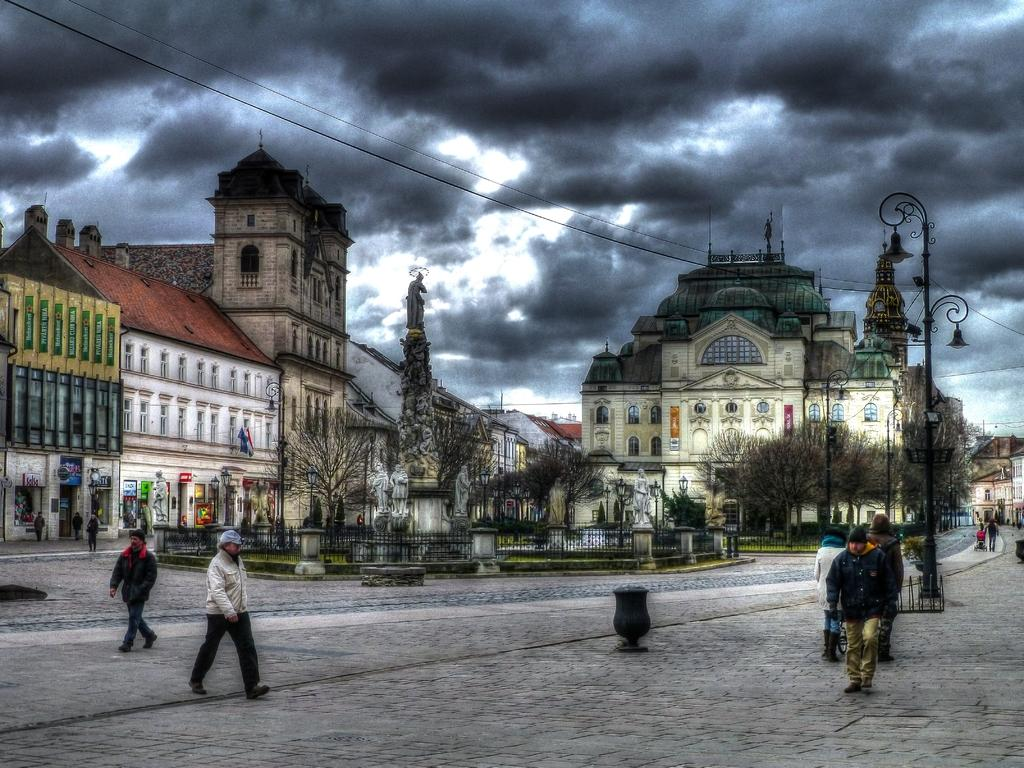What type of surface can be seen in the image? There is ground visible in the image. What are the persons in the image doing? The persons are standing on the ground. What structures can be seen in the image? There are poles, wires, trees, railing, and buildings in the image. What is visible in the background of the image? The sky is visible in the background of the image. How many clocks are visible on the buildings in the image? There are no clocks visible on the buildings in the image. What day of the week is it in the image? The day of the week cannot be determined from the image. 